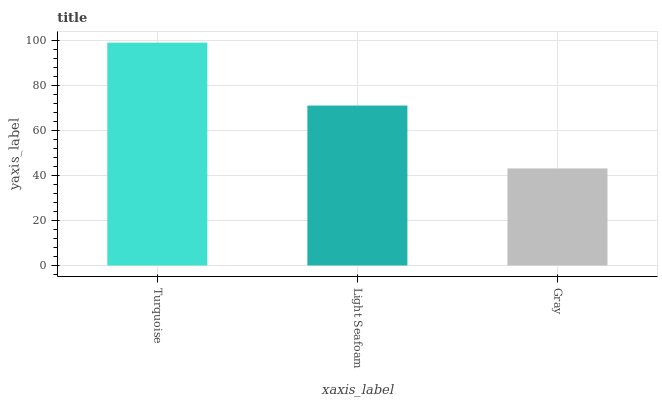Is Gray the minimum?
Answer yes or no. Yes. Is Turquoise the maximum?
Answer yes or no. Yes. Is Light Seafoam the minimum?
Answer yes or no. No. Is Light Seafoam the maximum?
Answer yes or no. No. Is Turquoise greater than Light Seafoam?
Answer yes or no. Yes. Is Light Seafoam less than Turquoise?
Answer yes or no. Yes. Is Light Seafoam greater than Turquoise?
Answer yes or no. No. Is Turquoise less than Light Seafoam?
Answer yes or no. No. Is Light Seafoam the high median?
Answer yes or no. Yes. Is Light Seafoam the low median?
Answer yes or no. Yes. Is Turquoise the high median?
Answer yes or no. No. Is Turquoise the low median?
Answer yes or no. No. 